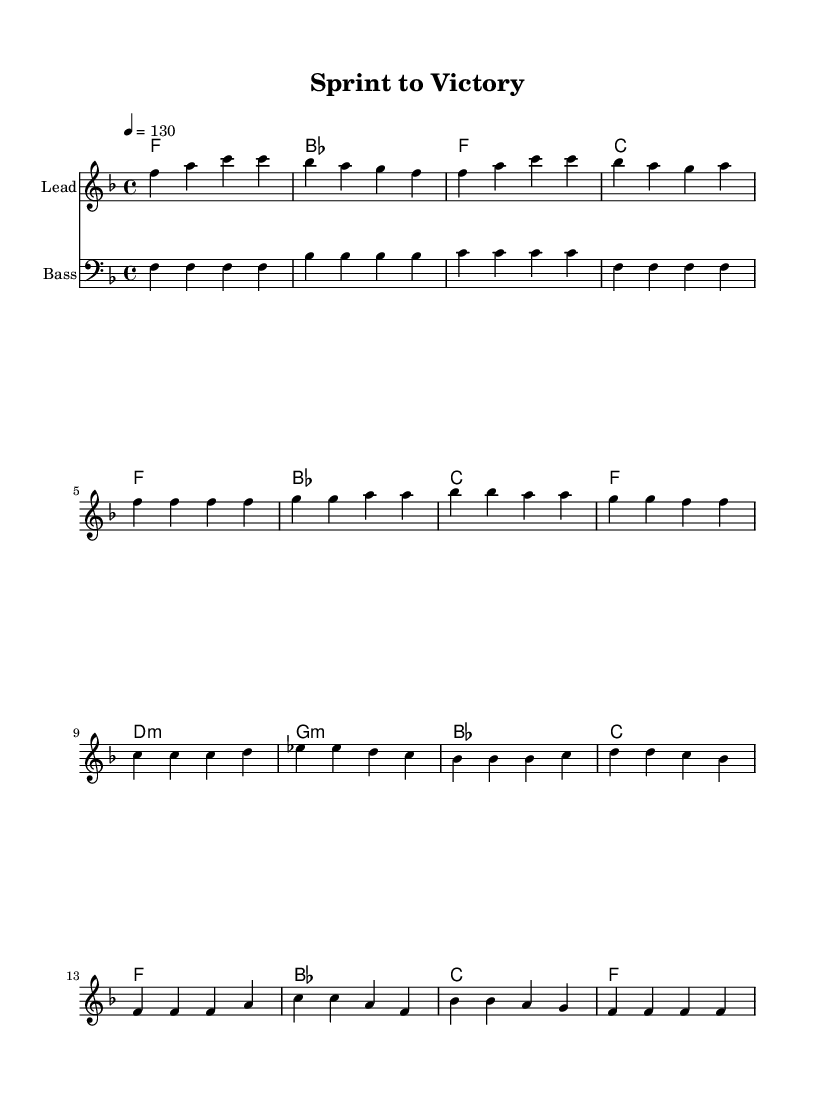What is the key signature of this music? The key signature shows one flat (B♭), indicating the key is F major, which consists of the notes F, G, A, B♭, C, D, and E.
Answer: F major What is the time signature of the piece? The time signature is displayed as 4/4, meaning there are four beats in each measure and the quarter note counts as one beat.
Answer: 4/4 What is the tempo marking of the song? The tempo marking indicates that the piece should be played at a speed of 130 beats per minute, which is a lively tempo fitting for disco music.
Answer: 130 What is the first chord of the intro section? The first chord in the intro section is F major, which is represented by the note F along with its third (A) and fifth (C), confirming it as the tonic chord of F major.
Answer: F How many measures are in the chorus section? By examining the score, we can see that the chorus section consists of four measures, highlighting its structured repetition found in disco music.
Answer: 4 Which section contains the most repetition? Upon analyzing the piece, the verse section shows a clear repetition pattern with several identical measures, characteristic of disco’s catchy and danceable style.
Answer: Verse What genre does this music belong to? The characteristics such as the upbeat tempo, syncopated rhythms, and prominent bass line confirm that this music is classified as disco, known for its danceable grooves.
Answer: Disco 